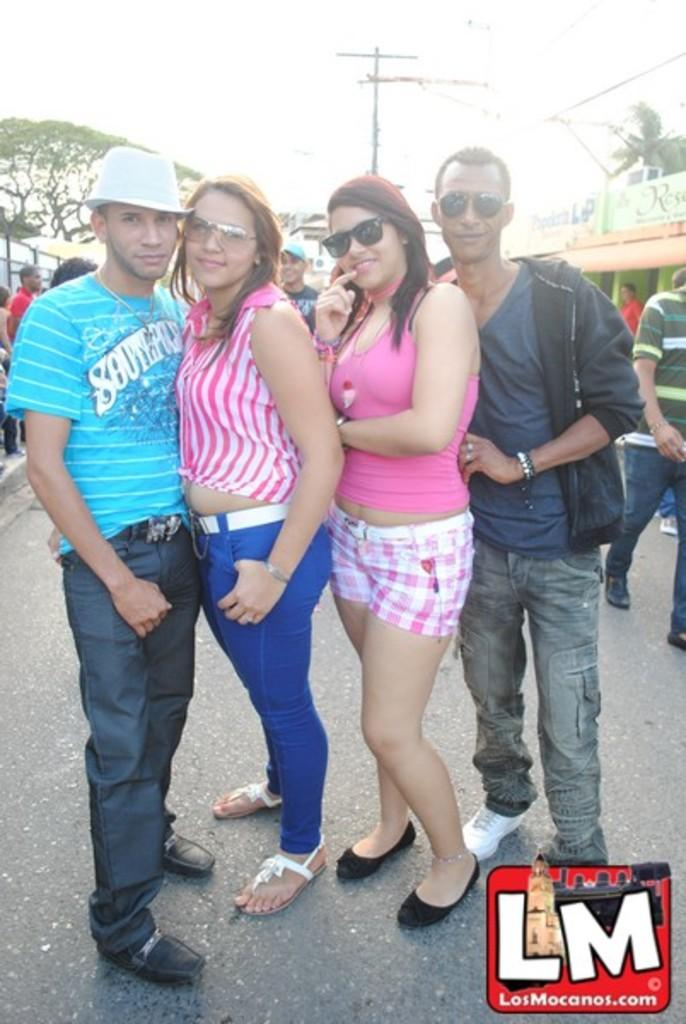How many people are in the image? There are four persons in the image. Where are the persons located in the image? The persons are on the road. What is the facial expression of the persons in the image? The persons are smiling. What are the persons doing in the image? The persons are posing for a camera. What can be seen in the background of the image? There are trees, poles, boards, and the sky visible in the background of the image. What type of laborer can be seen working on the boards in the image? There are no laborers or boards being worked on in the image; the persons are posing for a camera, and the boards are in the background. What substance is being used to create the trees in the image? The trees in the image are natural, and no substance is being used to create them. 